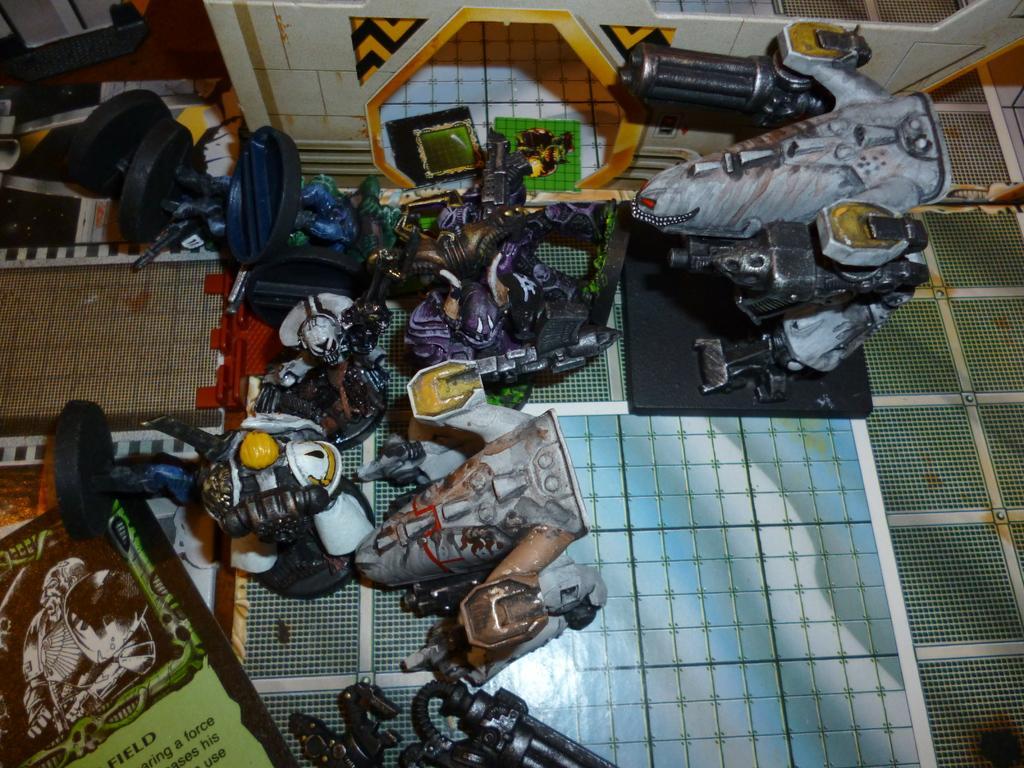In one or two sentences, can you explain what this image depicts? In this image I can see there are toys on the floor. And there is a design to the wall. And there is a banner with text and an image. 